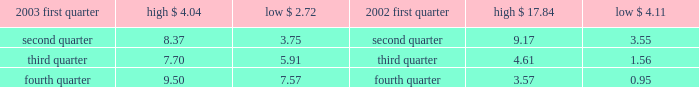Part ii item 5 .
Market for registrant 2019s common equity and related stockholder matters recent sales of unregistered securities during the fourth quarter of 2003 , aes issued an aggregated of 20.2 million shares of its common stock in exchange for $ 20 million aggregate principal amount of its senior notes .
The shares were issued without registration in reliance upon section 3 ( a ) ( 9 ) under the securities act of 1933 .
Market information our common stock is currently traded on the new york stock exchange ( 2018 2018nyse 2019 2019 ) under the symbol 2018 2018aes . 2019 2019 the tables set forth the high and low sale prices for our common stock as reported by the nyse for the periods indicated .
Price range of common stock .
Holders as of march 3 , 2004 , there were 9026 record holders of our common stock , par value $ 0.01 per share .
Dividends under the terms of our senior secured credit facilities , which we entered into with a commercial bank syndicate , we are not allowed to pay cash dividends .
In addition , under the terms of a guaranty we provided to the utility customer in connection with the aes thames project , we are precluded from paying cash dividends on our common stock if we do not meet certain net worth and liquidity tests .
Our project subsidiaries 2019 ability to declare and pay cash dividends to us is subject to certain limitations contained in the project loans , governmental provisions and other agreements that our project subsidiaries are subject to .
See item 12 ( d ) of this form 10-k for information regarding securities authorized for issuance under equity compensation plans. .
What was the difference in the low price for the first quarter of 2003 and the high price for the fourth quarter of 2002? 
Computations: (3.57 - 4.11)
Answer: -0.54. 